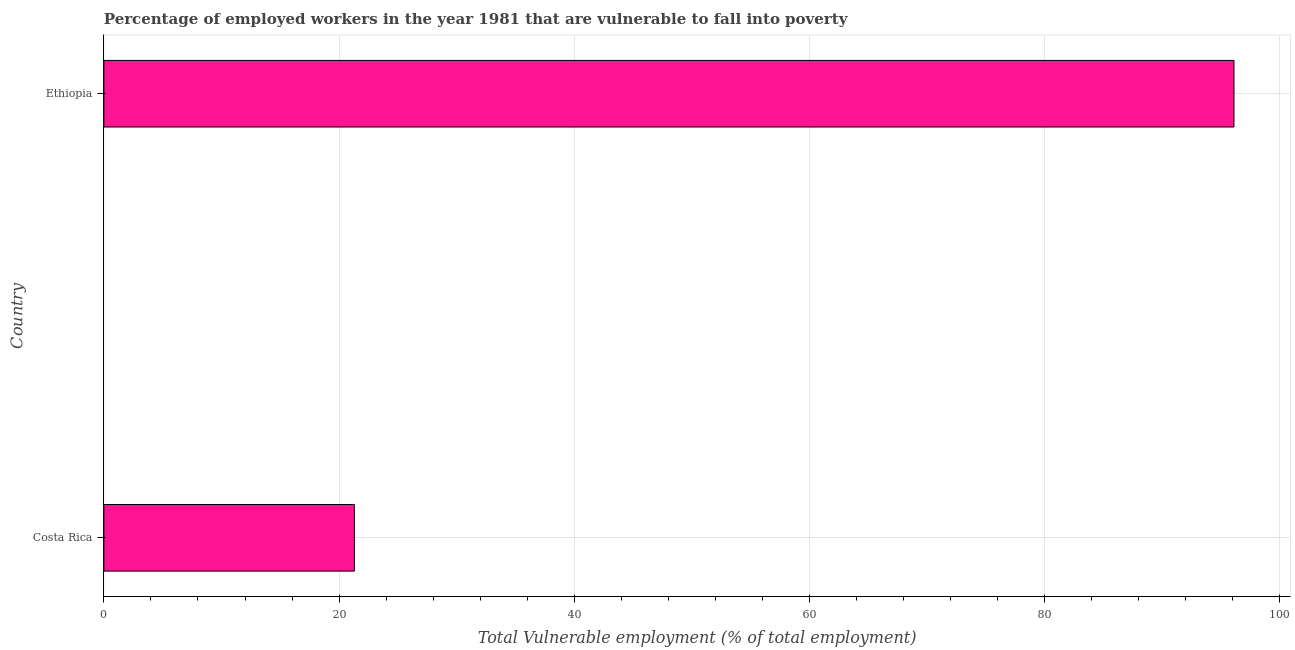Does the graph contain any zero values?
Your answer should be compact. No. Does the graph contain grids?
Your response must be concise. Yes. What is the title of the graph?
Your answer should be compact. Percentage of employed workers in the year 1981 that are vulnerable to fall into poverty. What is the label or title of the X-axis?
Ensure brevity in your answer.  Total Vulnerable employment (% of total employment). What is the label or title of the Y-axis?
Your response must be concise. Country. What is the total vulnerable employment in Ethiopia?
Your answer should be compact. 96.1. Across all countries, what is the maximum total vulnerable employment?
Your response must be concise. 96.1. Across all countries, what is the minimum total vulnerable employment?
Give a very brief answer. 21.3. In which country was the total vulnerable employment maximum?
Make the answer very short. Ethiopia. What is the sum of the total vulnerable employment?
Make the answer very short. 117.4. What is the difference between the total vulnerable employment in Costa Rica and Ethiopia?
Provide a short and direct response. -74.8. What is the average total vulnerable employment per country?
Keep it short and to the point. 58.7. What is the median total vulnerable employment?
Ensure brevity in your answer.  58.7. What is the ratio of the total vulnerable employment in Costa Rica to that in Ethiopia?
Provide a short and direct response. 0.22. How many bars are there?
Keep it short and to the point. 2. How many countries are there in the graph?
Your answer should be compact. 2. What is the Total Vulnerable employment (% of total employment) in Costa Rica?
Your answer should be compact. 21.3. What is the Total Vulnerable employment (% of total employment) in Ethiopia?
Offer a terse response. 96.1. What is the difference between the Total Vulnerable employment (% of total employment) in Costa Rica and Ethiopia?
Offer a terse response. -74.8. What is the ratio of the Total Vulnerable employment (% of total employment) in Costa Rica to that in Ethiopia?
Offer a very short reply. 0.22. 